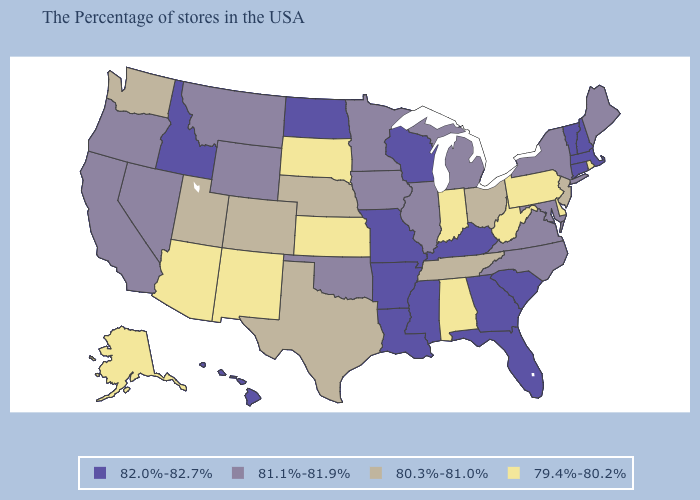What is the lowest value in the MidWest?
Give a very brief answer. 79.4%-80.2%. Among the states that border Kansas , does Missouri have the highest value?
Give a very brief answer. Yes. What is the value of Minnesota?
Keep it brief. 81.1%-81.9%. Does the first symbol in the legend represent the smallest category?
Quick response, please. No. Among the states that border Texas , does Louisiana have the lowest value?
Be succinct. No. Name the states that have a value in the range 80.3%-81.0%?
Answer briefly. New Jersey, Ohio, Tennessee, Nebraska, Texas, Colorado, Utah, Washington. What is the highest value in the USA?
Give a very brief answer. 82.0%-82.7%. Name the states that have a value in the range 80.3%-81.0%?
Keep it brief. New Jersey, Ohio, Tennessee, Nebraska, Texas, Colorado, Utah, Washington. What is the value of Delaware?
Short answer required. 79.4%-80.2%. What is the value of Maryland?
Write a very short answer. 81.1%-81.9%. Which states have the lowest value in the USA?
Give a very brief answer. Rhode Island, Delaware, Pennsylvania, West Virginia, Indiana, Alabama, Kansas, South Dakota, New Mexico, Arizona, Alaska. Does Minnesota have the highest value in the USA?
Keep it brief. No. Does West Virginia have the lowest value in the USA?
Quick response, please. Yes. What is the highest value in states that border New Hampshire?
Quick response, please. 82.0%-82.7%. 